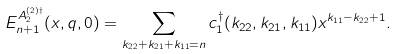<formula> <loc_0><loc_0><loc_500><loc_500>E _ { n + 1 } ^ { { A _ { 2 } ^ { ( 2 ) \dagger } } } ( x , q , 0 ) = \sum _ { k _ { 2 2 } + k _ { 2 1 } + k _ { 1 1 } = n } c _ { 1 } ^ { \dagger } ( k _ { 2 2 } , k _ { 2 1 } , k _ { 1 1 } ) x ^ { k _ { 1 1 } - k _ { 2 2 } + 1 } .</formula> 